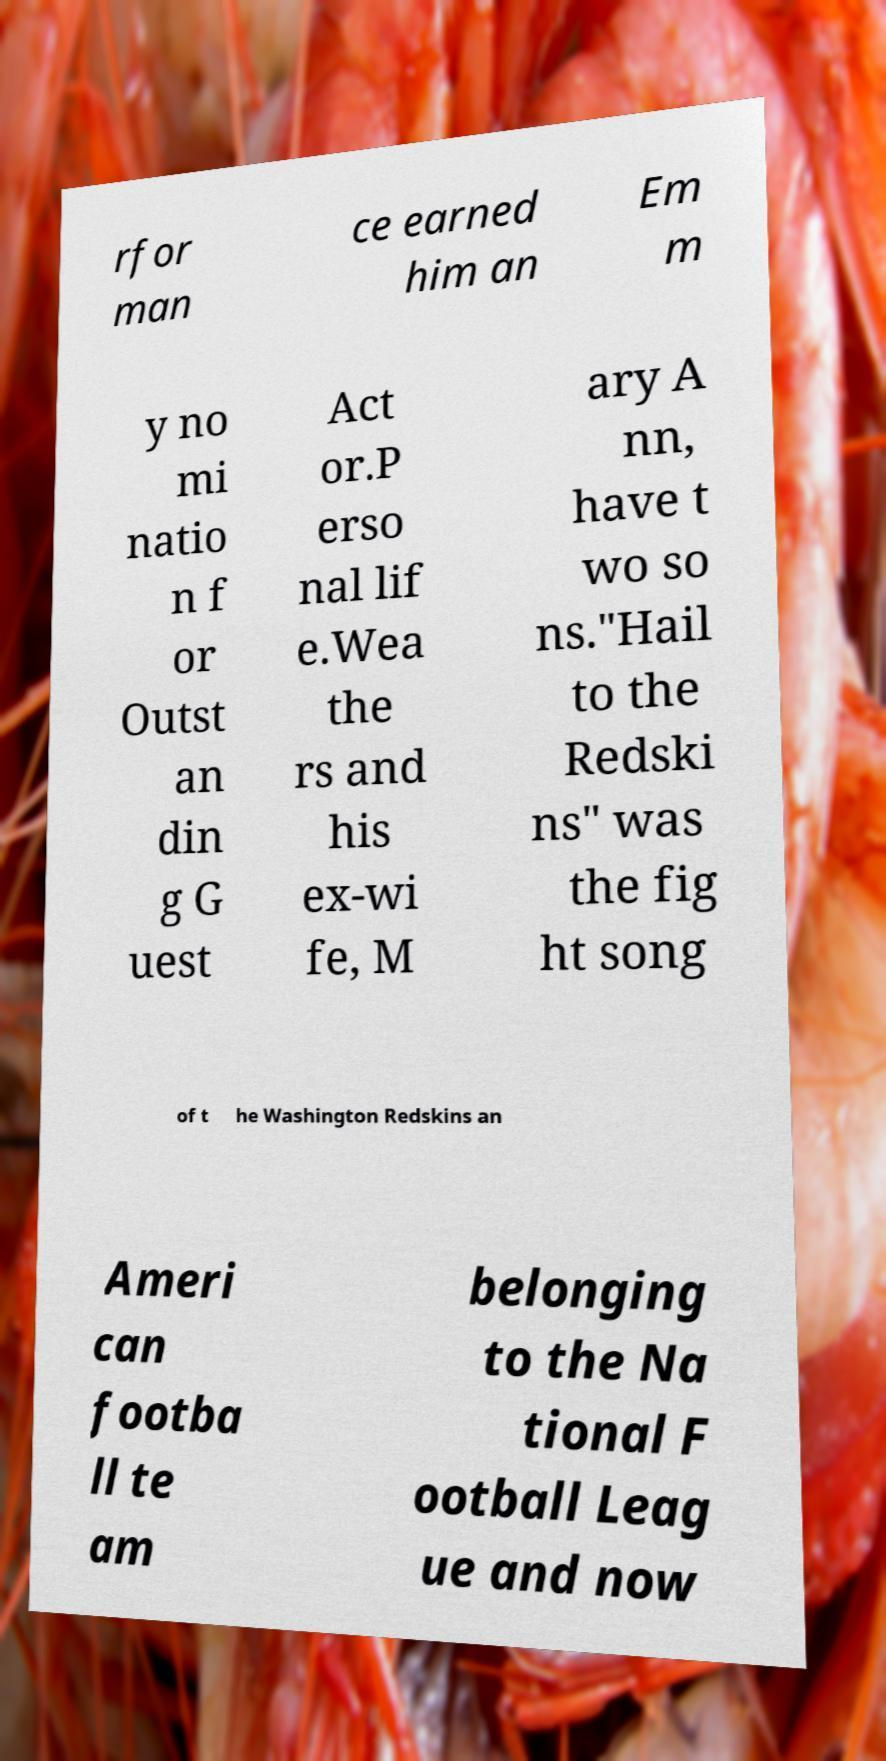Please identify and transcribe the text found in this image. rfor man ce earned him an Em m y no mi natio n f or Outst an din g G uest Act or.P erso nal lif e.Wea the rs and his ex-wi fe, M ary A nn, have t wo so ns."Hail to the Redski ns" was the fig ht song of t he Washington Redskins an Ameri can footba ll te am belonging to the Na tional F ootball Leag ue and now 